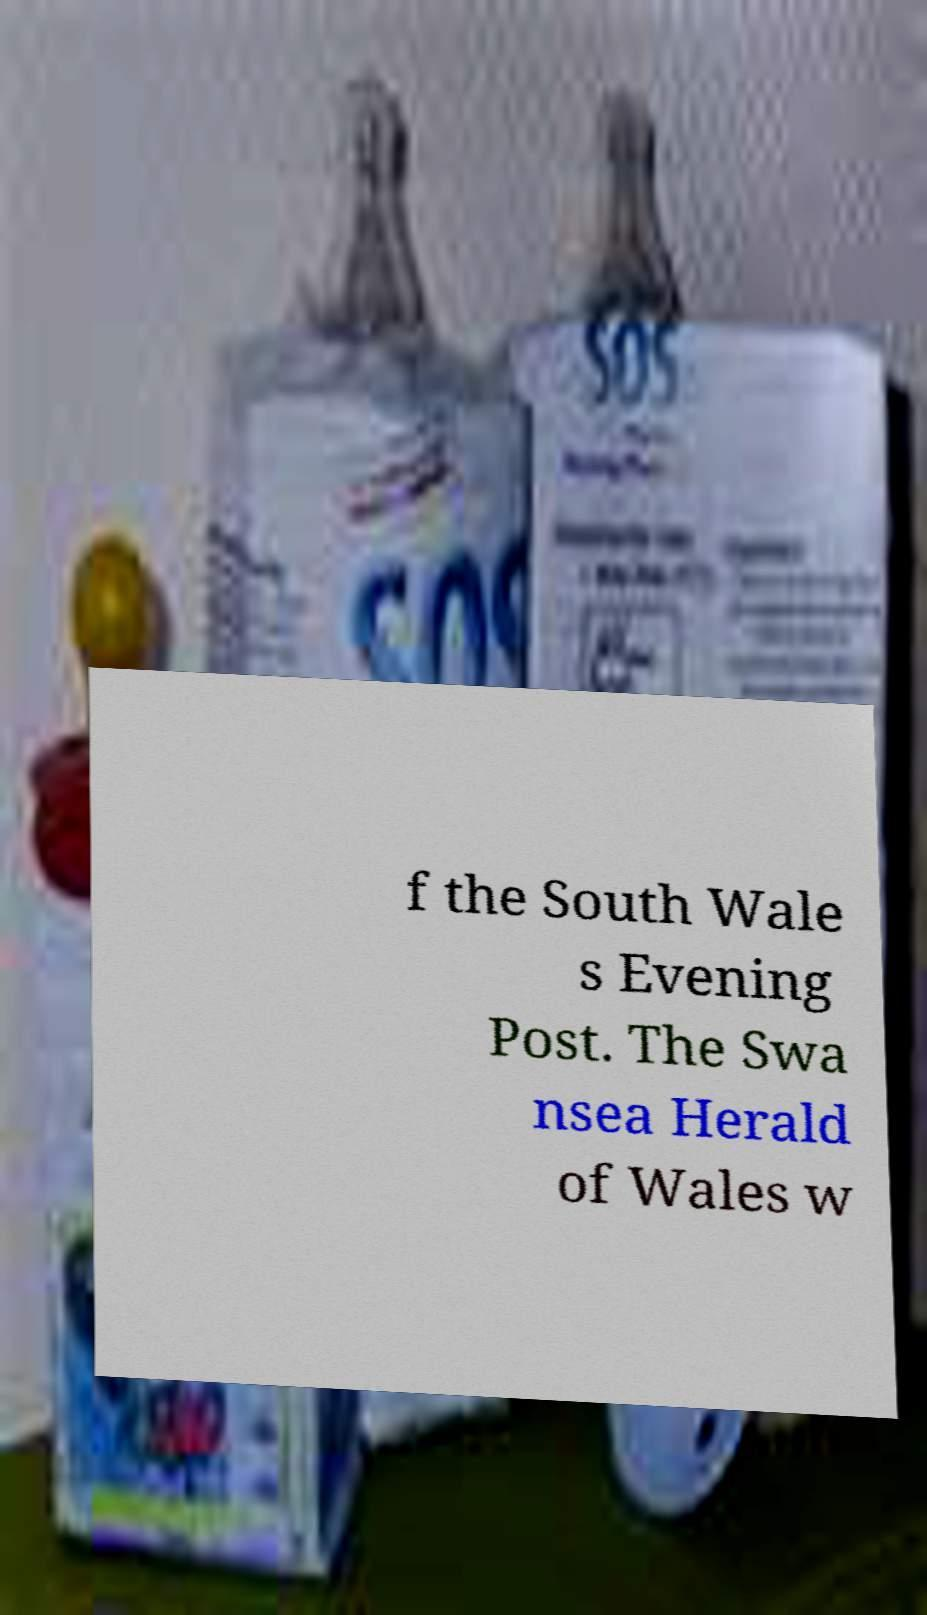What messages or text are displayed in this image? I need them in a readable, typed format. f the South Wale s Evening Post. The Swa nsea Herald of Wales w 